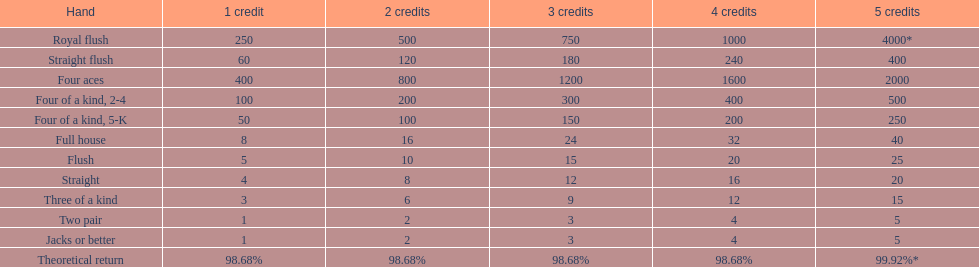The amount of flush triumphs at one credit to correspond to one flush triumph at 5 credits. 5. 